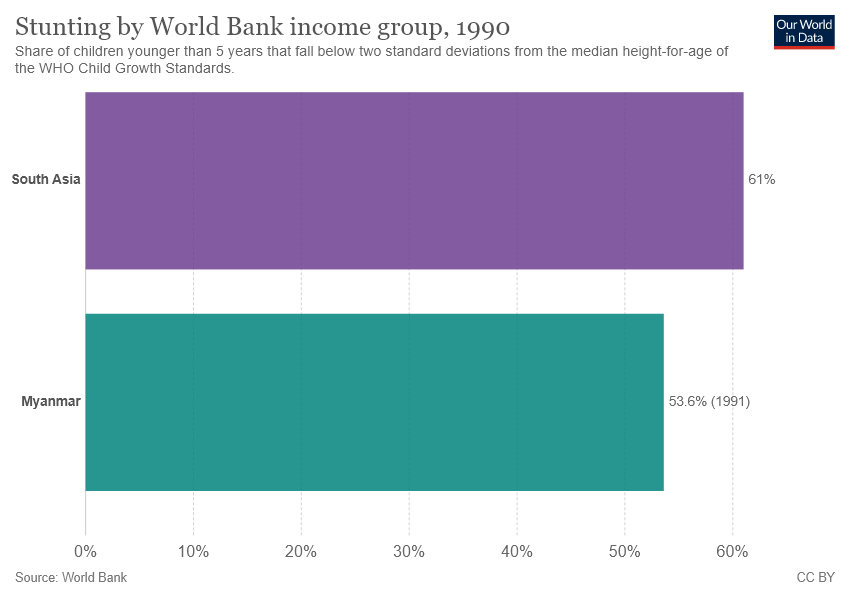Indicate a few pertinent items in this graphic. There are two bars in the graph. The average of both the bars is 57.3. 